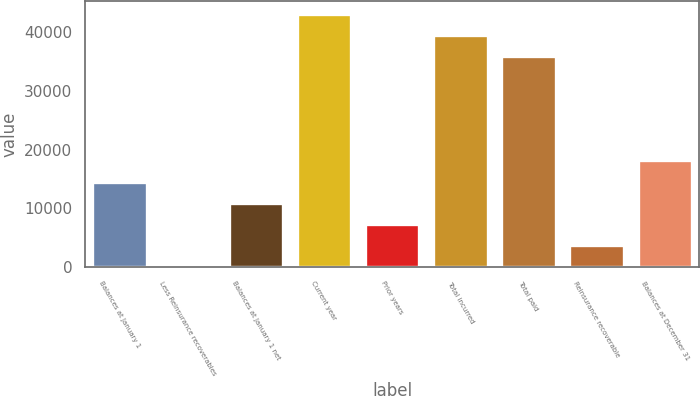Convert chart to OTSL. <chart><loc_0><loc_0><loc_500><loc_500><bar_chart><fcel>Balances at January 1<fcel>Less Reinsurance recoverables<fcel>Balances at January 1 net<fcel>Current year<fcel>Prior years<fcel>Total incurred<fcel>Total paid<fcel>Reinsurance recoverable<fcel>Balances at December 31<nl><fcel>14566.4<fcel>78<fcel>10944.3<fcel>43130.2<fcel>7322.2<fcel>39508.1<fcel>35886<fcel>3700.1<fcel>18188.5<nl></chart> 